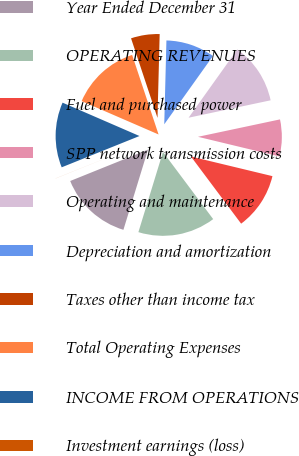Convert chart. <chart><loc_0><loc_0><loc_500><loc_500><pie_chart><fcel>Year Ended December 31<fcel>OPERATING REVENUES<fcel>Fuel and purchased power<fcel>SPP network transmission costs<fcel>Operating and maintenance<fcel>Depreciation and amortization<fcel>Taxes other than income tax<fcel>Total Operating Expenses<fcel>INCOME FROM OPERATIONS<fcel>Investment earnings (loss)<nl><fcel>14.17%<fcel>14.95%<fcel>11.02%<fcel>7.09%<fcel>11.81%<fcel>9.45%<fcel>5.52%<fcel>13.38%<fcel>12.6%<fcel>0.01%<nl></chart> 